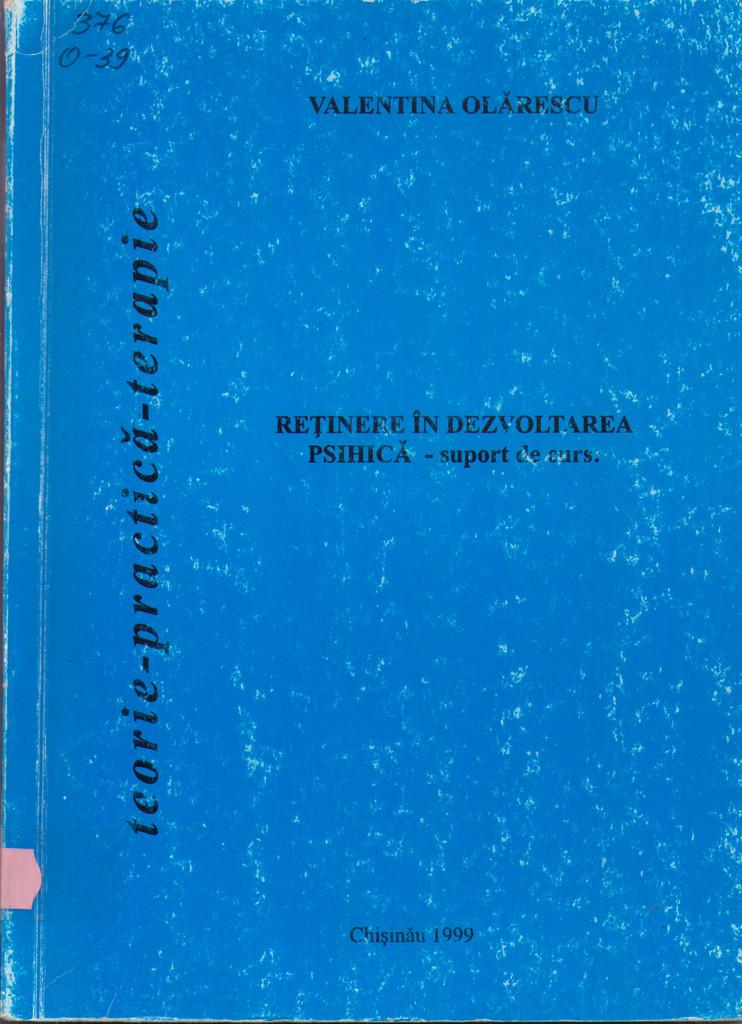Provide a one-sentence caption for the provided image. The blue book shown here was written in 1999. 